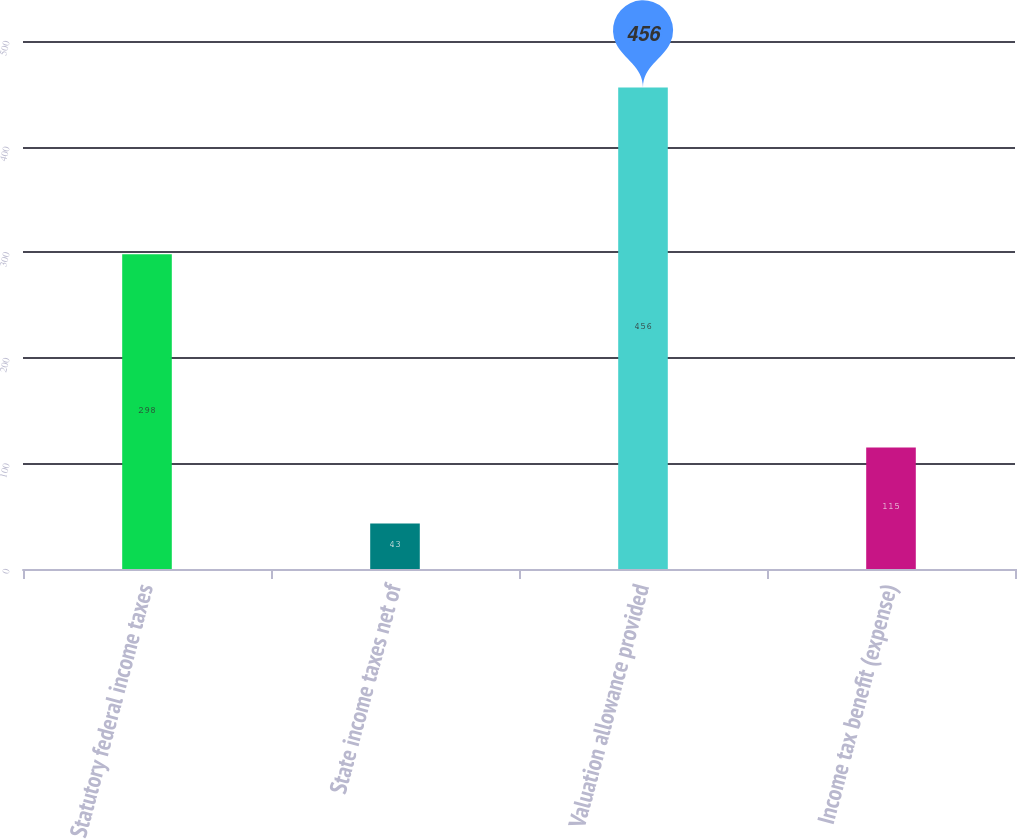Convert chart. <chart><loc_0><loc_0><loc_500><loc_500><bar_chart><fcel>Statutory federal income taxes<fcel>State income taxes net of<fcel>Valuation allowance provided<fcel>Income tax benefit (expense)<nl><fcel>298<fcel>43<fcel>456<fcel>115<nl></chart> 